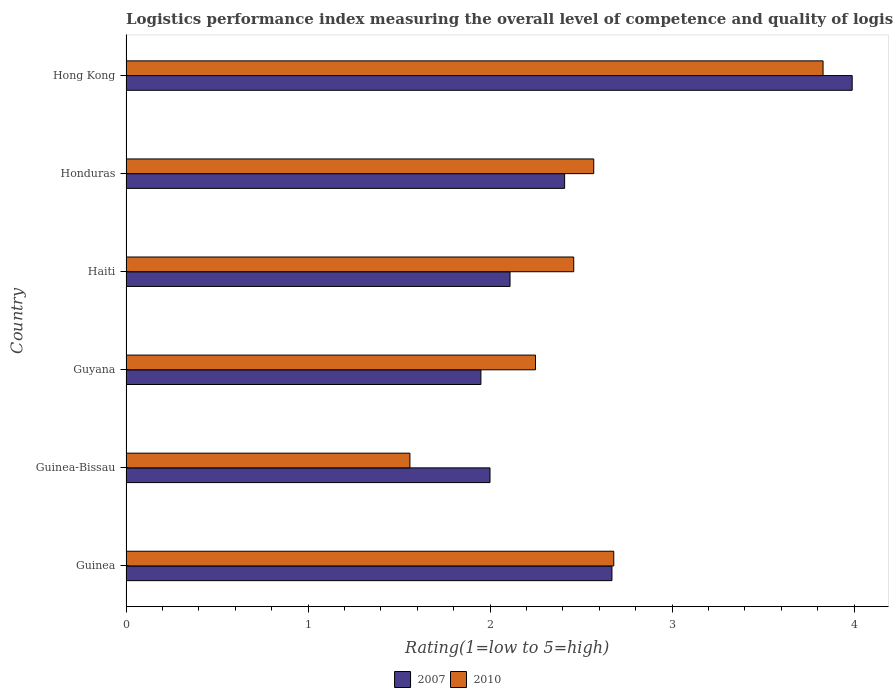How many different coloured bars are there?
Your answer should be compact. 2. Are the number of bars on each tick of the Y-axis equal?
Offer a very short reply. Yes. How many bars are there on the 1st tick from the top?
Keep it short and to the point. 2. How many bars are there on the 2nd tick from the bottom?
Provide a succinct answer. 2. What is the label of the 2nd group of bars from the top?
Provide a succinct answer. Honduras. What is the Logistic performance index in 2010 in Hong Kong?
Ensure brevity in your answer.  3.83. Across all countries, what is the maximum Logistic performance index in 2010?
Offer a terse response. 3.83. Across all countries, what is the minimum Logistic performance index in 2010?
Your response must be concise. 1.56. In which country was the Logistic performance index in 2010 maximum?
Your answer should be very brief. Hong Kong. In which country was the Logistic performance index in 2010 minimum?
Offer a terse response. Guinea-Bissau. What is the total Logistic performance index in 2007 in the graph?
Give a very brief answer. 15.13. What is the difference between the Logistic performance index in 2010 in Honduras and that in Hong Kong?
Your response must be concise. -1.26. What is the average Logistic performance index in 2010 per country?
Your response must be concise. 2.56. What is the difference between the Logistic performance index in 2010 and Logistic performance index in 2007 in Guyana?
Ensure brevity in your answer.  0.3. In how many countries, is the Logistic performance index in 2010 greater than 2.6 ?
Provide a succinct answer. 2. What is the ratio of the Logistic performance index in 2007 in Guinea to that in Guyana?
Make the answer very short. 1.37. Is the Logistic performance index in 2007 in Guyana less than that in Hong Kong?
Your response must be concise. Yes. Is the difference between the Logistic performance index in 2010 in Guinea-Bissau and Haiti greater than the difference between the Logistic performance index in 2007 in Guinea-Bissau and Haiti?
Give a very brief answer. No. What is the difference between the highest and the second highest Logistic performance index in 2007?
Give a very brief answer. 1.32. What is the difference between the highest and the lowest Logistic performance index in 2007?
Offer a very short reply. 2.04. In how many countries, is the Logistic performance index in 2007 greater than the average Logistic performance index in 2007 taken over all countries?
Your answer should be compact. 2. What does the 2nd bar from the bottom in Hong Kong represents?
Ensure brevity in your answer.  2010. How many countries are there in the graph?
Provide a succinct answer. 6. Are the values on the major ticks of X-axis written in scientific E-notation?
Make the answer very short. No. Does the graph contain any zero values?
Offer a very short reply. No. Does the graph contain grids?
Make the answer very short. No. Where does the legend appear in the graph?
Your response must be concise. Bottom center. What is the title of the graph?
Your response must be concise. Logistics performance index measuring the overall level of competence and quality of logistics services. Does "1990" appear as one of the legend labels in the graph?
Offer a very short reply. No. What is the label or title of the X-axis?
Give a very brief answer. Rating(1=low to 5=high). What is the label or title of the Y-axis?
Your response must be concise. Country. What is the Rating(1=low to 5=high) in 2007 in Guinea?
Make the answer very short. 2.67. What is the Rating(1=low to 5=high) of 2010 in Guinea?
Keep it short and to the point. 2.68. What is the Rating(1=low to 5=high) in 2007 in Guinea-Bissau?
Keep it short and to the point. 2. What is the Rating(1=low to 5=high) of 2010 in Guinea-Bissau?
Give a very brief answer. 1.56. What is the Rating(1=low to 5=high) in 2007 in Guyana?
Your response must be concise. 1.95. What is the Rating(1=low to 5=high) of 2010 in Guyana?
Ensure brevity in your answer.  2.25. What is the Rating(1=low to 5=high) of 2007 in Haiti?
Ensure brevity in your answer.  2.11. What is the Rating(1=low to 5=high) in 2010 in Haiti?
Offer a terse response. 2.46. What is the Rating(1=low to 5=high) of 2007 in Honduras?
Ensure brevity in your answer.  2.41. What is the Rating(1=low to 5=high) of 2010 in Honduras?
Offer a very short reply. 2.57. What is the Rating(1=low to 5=high) of 2007 in Hong Kong?
Keep it short and to the point. 3.99. What is the Rating(1=low to 5=high) of 2010 in Hong Kong?
Offer a very short reply. 3.83. Across all countries, what is the maximum Rating(1=low to 5=high) of 2007?
Provide a succinct answer. 3.99. Across all countries, what is the maximum Rating(1=low to 5=high) of 2010?
Your answer should be very brief. 3.83. Across all countries, what is the minimum Rating(1=low to 5=high) in 2007?
Give a very brief answer. 1.95. Across all countries, what is the minimum Rating(1=low to 5=high) of 2010?
Your answer should be compact. 1.56. What is the total Rating(1=low to 5=high) of 2007 in the graph?
Make the answer very short. 15.13. What is the total Rating(1=low to 5=high) in 2010 in the graph?
Ensure brevity in your answer.  15.35. What is the difference between the Rating(1=low to 5=high) of 2007 in Guinea and that in Guinea-Bissau?
Keep it short and to the point. 0.67. What is the difference between the Rating(1=low to 5=high) in 2010 in Guinea and that in Guinea-Bissau?
Ensure brevity in your answer.  1.12. What is the difference between the Rating(1=low to 5=high) of 2007 in Guinea and that in Guyana?
Give a very brief answer. 0.72. What is the difference between the Rating(1=low to 5=high) of 2010 in Guinea and that in Guyana?
Provide a short and direct response. 0.43. What is the difference between the Rating(1=low to 5=high) of 2007 in Guinea and that in Haiti?
Keep it short and to the point. 0.56. What is the difference between the Rating(1=low to 5=high) in 2010 in Guinea and that in Haiti?
Your answer should be compact. 0.22. What is the difference between the Rating(1=low to 5=high) of 2007 in Guinea and that in Honduras?
Make the answer very short. 0.26. What is the difference between the Rating(1=low to 5=high) in 2010 in Guinea and that in Honduras?
Keep it short and to the point. 0.11. What is the difference between the Rating(1=low to 5=high) of 2007 in Guinea and that in Hong Kong?
Provide a short and direct response. -1.32. What is the difference between the Rating(1=low to 5=high) in 2010 in Guinea and that in Hong Kong?
Ensure brevity in your answer.  -1.15. What is the difference between the Rating(1=low to 5=high) in 2010 in Guinea-Bissau and that in Guyana?
Provide a short and direct response. -0.69. What is the difference between the Rating(1=low to 5=high) of 2007 in Guinea-Bissau and that in Haiti?
Give a very brief answer. -0.11. What is the difference between the Rating(1=low to 5=high) of 2010 in Guinea-Bissau and that in Haiti?
Offer a very short reply. -0.9. What is the difference between the Rating(1=low to 5=high) of 2007 in Guinea-Bissau and that in Honduras?
Your response must be concise. -0.41. What is the difference between the Rating(1=low to 5=high) in 2010 in Guinea-Bissau and that in Honduras?
Offer a very short reply. -1.01. What is the difference between the Rating(1=low to 5=high) of 2007 in Guinea-Bissau and that in Hong Kong?
Offer a terse response. -1.99. What is the difference between the Rating(1=low to 5=high) of 2010 in Guinea-Bissau and that in Hong Kong?
Your response must be concise. -2.27. What is the difference between the Rating(1=low to 5=high) in 2007 in Guyana and that in Haiti?
Keep it short and to the point. -0.16. What is the difference between the Rating(1=low to 5=high) of 2010 in Guyana and that in Haiti?
Your answer should be compact. -0.21. What is the difference between the Rating(1=low to 5=high) in 2007 in Guyana and that in Honduras?
Keep it short and to the point. -0.46. What is the difference between the Rating(1=low to 5=high) in 2010 in Guyana and that in Honduras?
Provide a short and direct response. -0.32. What is the difference between the Rating(1=low to 5=high) in 2007 in Guyana and that in Hong Kong?
Your response must be concise. -2.04. What is the difference between the Rating(1=low to 5=high) in 2010 in Guyana and that in Hong Kong?
Your response must be concise. -1.58. What is the difference between the Rating(1=low to 5=high) of 2010 in Haiti and that in Honduras?
Ensure brevity in your answer.  -0.11. What is the difference between the Rating(1=low to 5=high) in 2007 in Haiti and that in Hong Kong?
Offer a terse response. -1.88. What is the difference between the Rating(1=low to 5=high) in 2010 in Haiti and that in Hong Kong?
Keep it short and to the point. -1.37. What is the difference between the Rating(1=low to 5=high) in 2007 in Honduras and that in Hong Kong?
Offer a very short reply. -1.58. What is the difference between the Rating(1=low to 5=high) in 2010 in Honduras and that in Hong Kong?
Give a very brief answer. -1.26. What is the difference between the Rating(1=low to 5=high) of 2007 in Guinea and the Rating(1=low to 5=high) of 2010 in Guinea-Bissau?
Make the answer very short. 1.11. What is the difference between the Rating(1=low to 5=high) of 2007 in Guinea and the Rating(1=low to 5=high) of 2010 in Guyana?
Provide a succinct answer. 0.42. What is the difference between the Rating(1=low to 5=high) in 2007 in Guinea and the Rating(1=low to 5=high) in 2010 in Haiti?
Your answer should be compact. 0.21. What is the difference between the Rating(1=low to 5=high) in 2007 in Guinea and the Rating(1=low to 5=high) in 2010 in Hong Kong?
Offer a terse response. -1.16. What is the difference between the Rating(1=low to 5=high) in 2007 in Guinea-Bissau and the Rating(1=low to 5=high) in 2010 in Guyana?
Offer a very short reply. -0.25. What is the difference between the Rating(1=low to 5=high) of 2007 in Guinea-Bissau and the Rating(1=low to 5=high) of 2010 in Haiti?
Keep it short and to the point. -0.46. What is the difference between the Rating(1=low to 5=high) in 2007 in Guinea-Bissau and the Rating(1=low to 5=high) in 2010 in Honduras?
Make the answer very short. -0.57. What is the difference between the Rating(1=low to 5=high) in 2007 in Guinea-Bissau and the Rating(1=low to 5=high) in 2010 in Hong Kong?
Ensure brevity in your answer.  -1.83. What is the difference between the Rating(1=low to 5=high) of 2007 in Guyana and the Rating(1=low to 5=high) of 2010 in Haiti?
Offer a terse response. -0.51. What is the difference between the Rating(1=low to 5=high) in 2007 in Guyana and the Rating(1=low to 5=high) in 2010 in Honduras?
Provide a short and direct response. -0.62. What is the difference between the Rating(1=low to 5=high) in 2007 in Guyana and the Rating(1=low to 5=high) in 2010 in Hong Kong?
Your answer should be compact. -1.88. What is the difference between the Rating(1=low to 5=high) of 2007 in Haiti and the Rating(1=low to 5=high) of 2010 in Honduras?
Offer a terse response. -0.46. What is the difference between the Rating(1=low to 5=high) in 2007 in Haiti and the Rating(1=low to 5=high) in 2010 in Hong Kong?
Provide a succinct answer. -1.72. What is the difference between the Rating(1=low to 5=high) in 2007 in Honduras and the Rating(1=low to 5=high) in 2010 in Hong Kong?
Your answer should be very brief. -1.42. What is the average Rating(1=low to 5=high) in 2007 per country?
Keep it short and to the point. 2.52. What is the average Rating(1=low to 5=high) of 2010 per country?
Provide a succinct answer. 2.56. What is the difference between the Rating(1=low to 5=high) in 2007 and Rating(1=low to 5=high) in 2010 in Guinea?
Make the answer very short. -0.01. What is the difference between the Rating(1=low to 5=high) of 2007 and Rating(1=low to 5=high) of 2010 in Guinea-Bissau?
Provide a succinct answer. 0.44. What is the difference between the Rating(1=low to 5=high) in 2007 and Rating(1=low to 5=high) in 2010 in Haiti?
Ensure brevity in your answer.  -0.35. What is the difference between the Rating(1=low to 5=high) of 2007 and Rating(1=low to 5=high) of 2010 in Honduras?
Provide a short and direct response. -0.16. What is the difference between the Rating(1=low to 5=high) of 2007 and Rating(1=low to 5=high) of 2010 in Hong Kong?
Offer a terse response. 0.16. What is the ratio of the Rating(1=low to 5=high) in 2007 in Guinea to that in Guinea-Bissau?
Your answer should be very brief. 1.33. What is the ratio of the Rating(1=low to 5=high) of 2010 in Guinea to that in Guinea-Bissau?
Provide a succinct answer. 1.72. What is the ratio of the Rating(1=low to 5=high) of 2007 in Guinea to that in Guyana?
Offer a very short reply. 1.37. What is the ratio of the Rating(1=low to 5=high) of 2010 in Guinea to that in Guyana?
Provide a short and direct response. 1.19. What is the ratio of the Rating(1=low to 5=high) of 2007 in Guinea to that in Haiti?
Keep it short and to the point. 1.27. What is the ratio of the Rating(1=low to 5=high) in 2010 in Guinea to that in Haiti?
Keep it short and to the point. 1.09. What is the ratio of the Rating(1=low to 5=high) of 2007 in Guinea to that in Honduras?
Offer a terse response. 1.11. What is the ratio of the Rating(1=low to 5=high) in 2010 in Guinea to that in Honduras?
Offer a very short reply. 1.04. What is the ratio of the Rating(1=low to 5=high) in 2007 in Guinea to that in Hong Kong?
Offer a terse response. 0.67. What is the ratio of the Rating(1=low to 5=high) in 2010 in Guinea to that in Hong Kong?
Offer a very short reply. 0.7. What is the ratio of the Rating(1=low to 5=high) in 2007 in Guinea-Bissau to that in Guyana?
Your response must be concise. 1.03. What is the ratio of the Rating(1=low to 5=high) of 2010 in Guinea-Bissau to that in Guyana?
Your response must be concise. 0.69. What is the ratio of the Rating(1=low to 5=high) in 2007 in Guinea-Bissau to that in Haiti?
Your answer should be compact. 0.95. What is the ratio of the Rating(1=low to 5=high) in 2010 in Guinea-Bissau to that in Haiti?
Offer a terse response. 0.63. What is the ratio of the Rating(1=low to 5=high) in 2007 in Guinea-Bissau to that in Honduras?
Provide a succinct answer. 0.83. What is the ratio of the Rating(1=low to 5=high) in 2010 in Guinea-Bissau to that in Honduras?
Provide a short and direct response. 0.61. What is the ratio of the Rating(1=low to 5=high) of 2007 in Guinea-Bissau to that in Hong Kong?
Provide a succinct answer. 0.5. What is the ratio of the Rating(1=low to 5=high) in 2010 in Guinea-Bissau to that in Hong Kong?
Your answer should be compact. 0.41. What is the ratio of the Rating(1=low to 5=high) of 2007 in Guyana to that in Haiti?
Provide a succinct answer. 0.92. What is the ratio of the Rating(1=low to 5=high) in 2010 in Guyana to that in Haiti?
Give a very brief answer. 0.91. What is the ratio of the Rating(1=low to 5=high) in 2007 in Guyana to that in Honduras?
Make the answer very short. 0.81. What is the ratio of the Rating(1=low to 5=high) in 2010 in Guyana to that in Honduras?
Provide a succinct answer. 0.88. What is the ratio of the Rating(1=low to 5=high) in 2007 in Guyana to that in Hong Kong?
Provide a succinct answer. 0.49. What is the ratio of the Rating(1=low to 5=high) of 2010 in Guyana to that in Hong Kong?
Provide a short and direct response. 0.59. What is the ratio of the Rating(1=low to 5=high) of 2007 in Haiti to that in Honduras?
Offer a very short reply. 0.88. What is the ratio of the Rating(1=low to 5=high) in 2010 in Haiti to that in Honduras?
Provide a succinct answer. 0.96. What is the ratio of the Rating(1=low to 5=high) of 2007 in Haiti to that in Hong Kong?
Offer a terse response. 0.53. What is the ratio of the Rating(1=low to 5=high) in 2010 in Haiti to that in Hong Kong?
Offer a very short reply. 0.64. What is the ratio of the Rating(1=low to 5=high) of 2007 in Honduras to that in Hong Kong?
Provide a succinct answer. 0.6. What is the ratio of the Rating(1=low to 5=high) of 2010 in Honduras to that in Hong Kong?
Your answer should be very brief. 0.67. What is the difference between the highest and the second highest Rating(1=low to 5=high) in 2007?
Your response must be concise. 1.32. What is the difference between the highest and the second highest Rating(1=low to 5=high) in 2010?
Provide a succinct answer. 1.15. What is the difference between the highest and the lowest Rating(1=low to 5=high) of 2007?
Provide a succinct answer. 2.04. What is the difference between the highest and the lowest Rating(1=low to 5=high) of 2010?
Give a very brief answer. 2.27. 